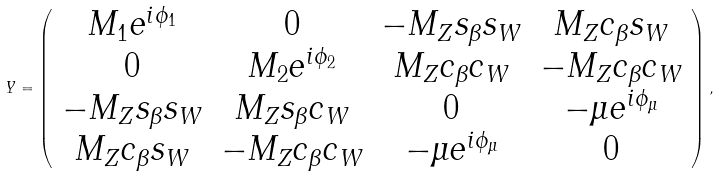<formula> <loc_0><loc_0><loc_500><loc_500>Y = \left ( \begin{array} { c c c c } M _ { 1 } e ^ { i \phi _ { 1 } } & 0 & - M _ { Z } s _ { \beta } s _ { W } & M _ { Z } c _ { \beta } s _ { W } \\ 0 & M _ { 2 } e ^ { i \phi _ { 2 } } & M _ { Z } c _ { \beta } c _ { W } & - M _ { Z } c _ { \beta } c _ { W } \\ - M _ { Z } s _ { \beta } s _ { W } & M _ { Z } s _ { \beta } c _ { W } & 0 & - { \mu } e ^ { i \phi _ { \mu } } \\ M _ { Z } c _ { \beta } s _ { W } & - M _ { Z } c _ { \beta } c _ { W } & - { \mu } e ^ { i \phi _ { \mu } } & 0 \\ \end{array} \right ) ,</formula> 